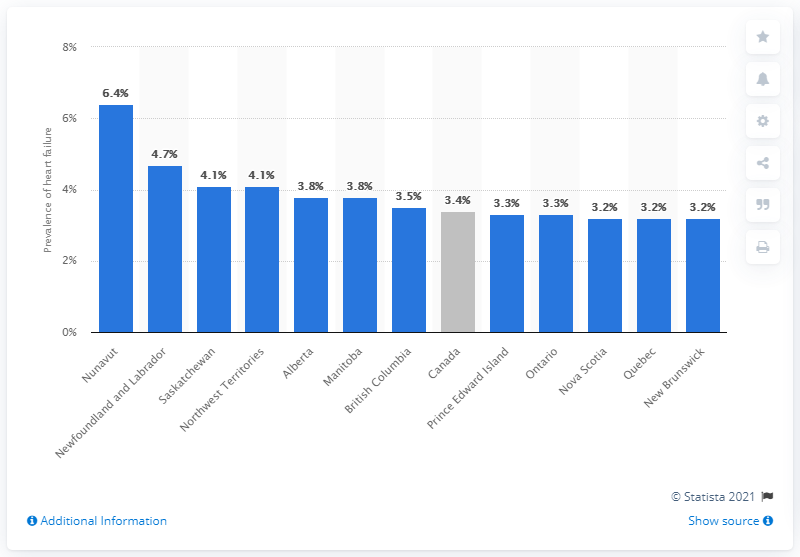Give some essential details in this illustration. The prevalence of heart failure in Nova Scotia is 3.2%. According to the provided information, the prevalence of heart failure is particularly high among individuals aged 40 years and older in Canada. 